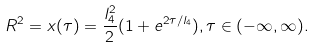Convert formula to latex. <formula><loc_0><loc_0><loc_500><loc_500>R ^ { 2 } = x ( \tau ) = \frac { l _ { 4 } ^ { 2 } } { 2 } ( 1 + e ^ { 2 \tau / l _ { 4 } } ) , \tau \in ( - \infty , \infty ) .</formula> 